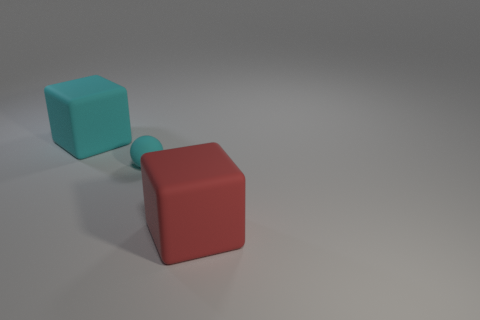There is a cyan matte object behind the cyan object on the right side of the block behind the tiny cyan sphere; how big is it?
Make the answer very short. Large. What number of objects are the same size as the red rubber block?
Provide a succinct answer. 1. How many objects are either tiny yellow shiny blocks or large red objects in front of the cyan matte sphere?
Offer a very short reply. 1. The large red thing is what shape?
Offer a very short reply. Cube. There is another matte thing that is the same size as the red rubber thing; what is its color?
Give a very brief answer. Cyan. What number of red things are either rubber cubes or tiny matte things?
Make the answer very short. 1. Are there more cyan spheres than purple matte cylinders?
Provide a short and direct response. Yes. Is the size of the rubber cube that is left of the large red rubber thing the same as the red object that is in front of the small ball?
Your response must be concise. Yes. What color is the cube that is on the left side of the large red rubber cube to the right of the big block that is behind the cyan matte ball?
Make the answer very short. Cyan. Are there any big red matte objects that have the same shape as the tiny cyan matte object?
Offer a terse response. No. 